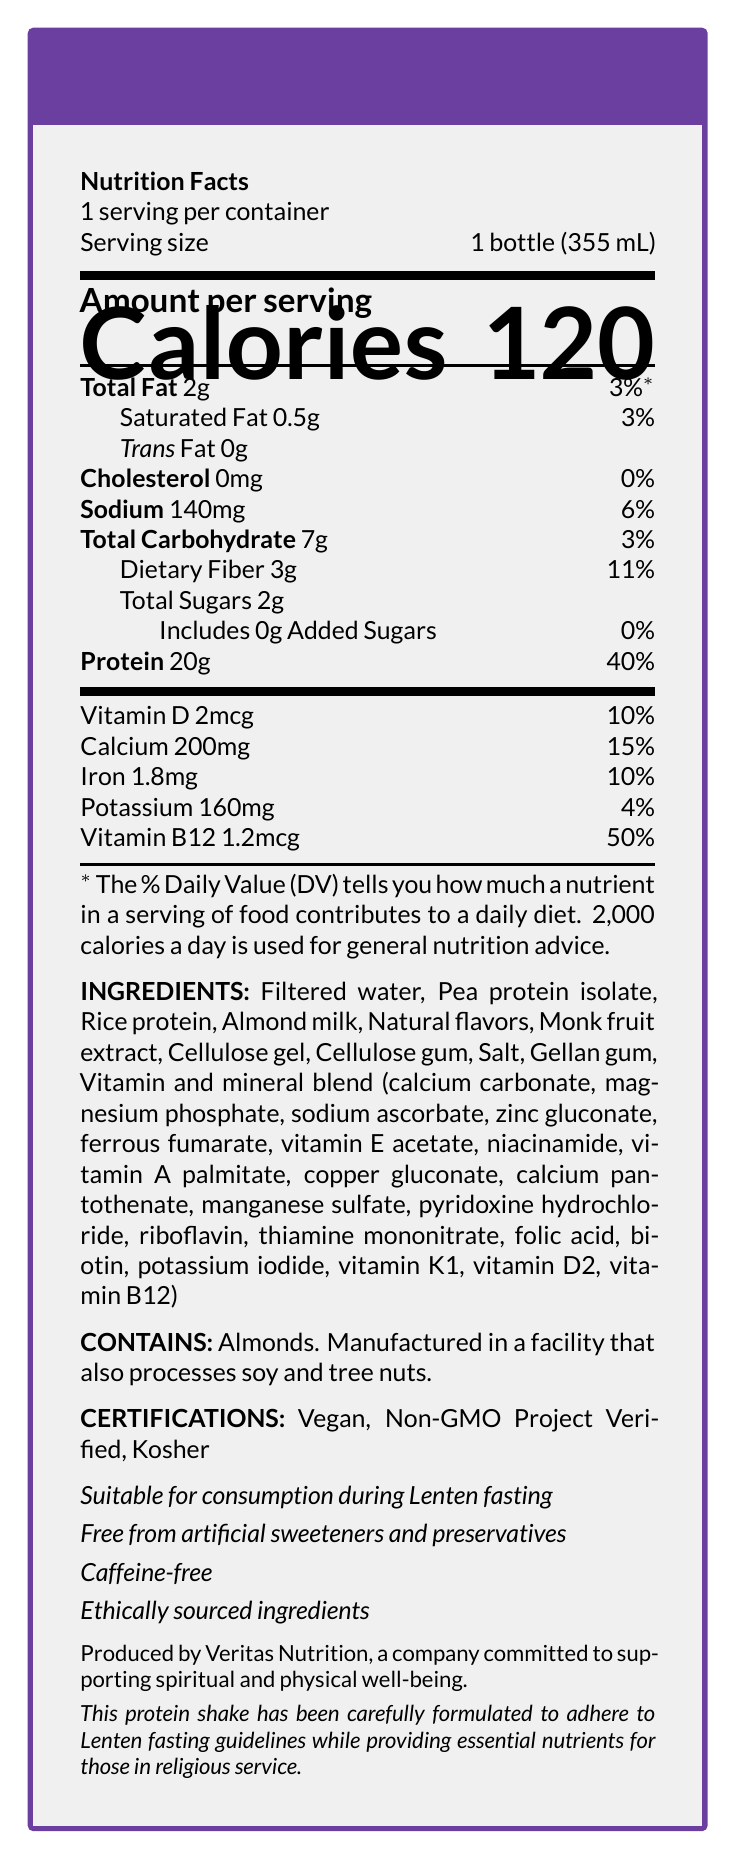what is the serving size for the LenTein Fasting-Friendly Protein Shake? The serving size is explicitly mentioned in the serving size section of the document.
Answer: 1 bottle (355 mL) how much protein is in one serving? The amount of protein per serving is listed under the "Protein" section of the Nutrition Facts.
Answer: 20g what allergens are present in the LenTein Fasting-Friendly Protein Shake? The allergen information is clearly indicated in the "CONTAINS" section of the document.
Answer: Contains almonds. what are the certifications listed for this product? The certifications are given in the "CERTIFICATIONS" section of the document.
Answer: Vegan, Non-GMO Project Verified, Kosher what is the caloric content per serving? The calories per serving are prominently displayed in the "Amount per serving" section.
Answer: 120 calories which of the following vitamins have the highest daily value percentage in one serving? A. Vitamin D B. Calcium C. Iron D. Vitamin B12 Vitamin B12 has a daily value percentage of 50%, which is higher than the other vitamins listed.
Answer: D. Vitamin B12 what is the total fat content in one serving? A. 2g B. 3g C. 4g D. 5g The total fat content is listed as 2g in the Nutrition Facts section.
Answer: A. 2g does this product include any added sugars? (Yes/No) The document states that the shake includes 0g of added sugars.
Answer: No describe the most important information conveyed by this document. This document provides detailed information about the nutritional content, ingredients, allergen information, and certifications of the LenTein Fasting-Friendly Protein Shake.
Answer: The LenTein Fasting-Friendly Protein Shake is a nutritious beverage specially designed for Lenten fasting. It contains essential nutrients, is allergen-friendly, and carries certifications like Vegan, Non-GMO, and Kosher. how many vitamins are listed in the nutritional information? The document lists Vitamin D, Calcium, Iron, and Vitamin B12 in the nutritional information section.
Answer: 4 where is this product manufactured? The location of manufacturing is not mentioned anywhere in the document; hence, this information cannot be determined from the visual.
Answer: Not enough information 